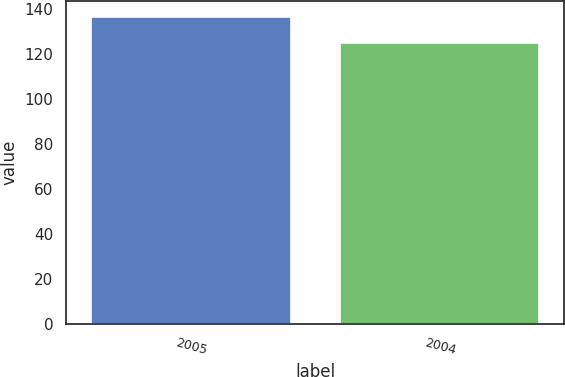<chart> <loc_0><loc_0><loc_500><loc_500><bar_chart><fcel>2005<fcel>2004<nl><fcel>136.6<fcel>124.8<nl></chart> 